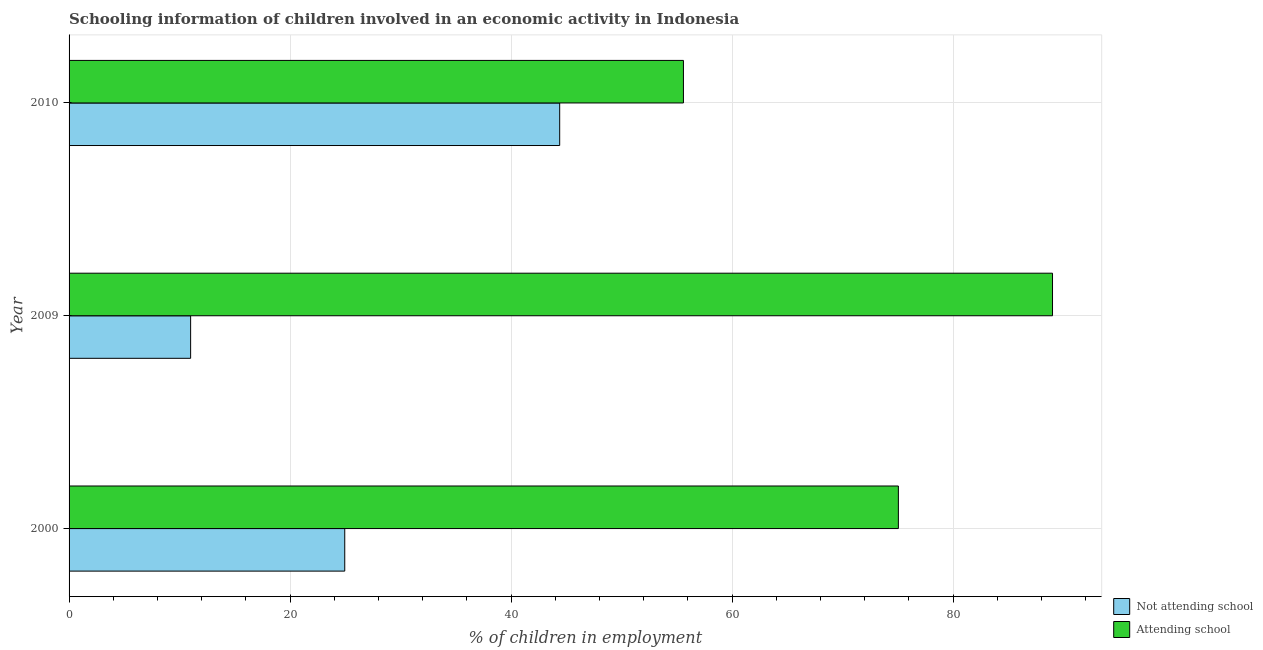Are the number of bars per tick equal to the number of legend labels?
Provide a short and direct response. Yes. Are the number of bars on each tick of the Y-axis equal?
Offer a terse response. Yes. How many bars are there on the 1st tick from the top?
Provide a short and direct response. 2. What is the percentage of employed children who are not attending school in 2000?
Ensure brevity in your answer.  24.95. Across all years, what is the maximum percentage of employed children who are attending school?
Offer a very short reply. 89. Across all years, what is the minimum percentage of employed children who are attending school?
Offer a very short reply. 55.6. What is the total percentage of employed children who are attending school in the graph?
Keep it short and to the point. 219.65. What is the difference between the percentage of employed children who are attending school in 2009 and that in 2010?
Offer a terse response. 33.4. What is the difference between the percentage of employed children who are attending school in 2000 and the percentage of employed children who are not attending school in 2010?
Provide a short and direct response. 30.65. What is the average percentage of employed children who are not attending school per year?
Provide a succinct answer. 26.78. In the year 2000, what is the difference between the percentage of employed children who are attending school and percentage of employed children who are not attending school?
Your answer should be compact. 50.1. In how many years, is the percentage of employed children who are attending school greater than 28 %?
Your answer should be very brief. 3. What is the ratio of the percentage of employed children who are attending school in 2000 to that in 2010?
Give a very brief answer. 1.35. Is the percentage of employed children who are attending school in 2000 less than that in 2010?
Provide a succinct answer. No. What is the difference between the highest and the second highest percentage of employed children who are attending school?
Provide a short and direct response. 13.95. What is the difference between the highest and the lowest percentage of employed children who are attending school?
Your answer should be very brief. 33.4. In how many years, is the percentage of employed children who are not attending school greater than the average percentage of employed children who are not attending school taken over all years?
Your response must be concise. 1. What does the 1st bar from the top in 2009 represents?
Give a very brief answer. Attending school. What does the 1st bar from the bottom in 2000 represents?
Make the answer very short. Not attending school. How many bars are there?
Your answer should be compact. 6. How many years are there in the graph?
Ensure brevity in your answer.  3. What is the difference between two consecutive major ticks on the X-axis?
Offer a very short reply. 20. Does the graph contain grids?
Your answer should be very brief. Yes. How many legend labels are there?
Keep it short and to the point. 2. What is the title of the graph?
Keep it short and to the point. Schooling information of children involved in an economic activity in Indonesia. Does "Fixed telephone" appear as one of the legend labels in the graph?
Offer a terse response. No. What is the label or title of the X-axis?
Give a very brief answer. % of children in employment. What is the % of children in employment of Not attending school in 2000?
Offer a very short reply. 24.95. What is the % of children in employment of Attending school in 2000?
Offer a very short reply. 75.05. What is the % of children in employment of Attending school in 2009?
Make the answer very short. 89. What is the % of children in employment in Not attending school in 2010?
Provide a succinct answer. 44.4. What is the % of children in employment of Attending school in 2010?
Make the answer very short. 55.6. Across all years, what is the maximum % of children in employment of Not attending school?
Give a very brief answer. 44.4. Across all years, what is the maximum % of children in employment in Attending school?
Give a very brief answer. 89. Across all years, what is the minimum % of children in employment of Attending school?
Your answer should be very brief. 55.6. What is the total % of children in employment of Not attending school in the graph?
Offer a very short reply. 80.35. What is the total % of children in employment of Attending school in the graph?
Make the answer very short. 219.65. What is the difference between the % of children in employment of Not attending school in 2000 and that in 2009?
Ensure brevity in your answer.  13.95. What is the difference between the % of children in employment in Attending school in 2000 and that in 2009?
Make the answer very short. -13.95. What is the difference between the % of children in employment of Not attending school in 2000 and that in 2010?
Make the answer very short. -19.45. What is the difference between the % of children in employment of Attending school in 2000 and that in 2010?
Provide a short and direct response. 19.45. What is the difference between the % of children in employment of Not attending school in 2009 and that in 2010?
Provide a short and direct response. -33.4. What is the difference between the % of children in employment in Attending school in 2009 and that in 2010?
Your response must be concise. 33.4. What is the difference between the % of children in employment in Not attending school in 2000 and the % of children in employment in Attending school in 2009?
Make the answer very short. -64.05. What is the difference between the % of children in employment in Not attending school in 2000 and the % of children in employment in Attending school in 2010?
Keep it short and to the point. -30.65. What is the difference between the % of children in employment in Not attending school in 2009 and the % of children in employment in Attending school in 2010?
Your response must be concise. -44.6. What is the average % of children in employment in Not attending school per year?
Ensure brevity in your answer.  26.78. What is the average % of children in employment in Attending school per year?
Your answer should be compact. 73.22. In the year 2000, what is the difference between the % of children in employment of Not attending school and % of children in employment of Attending school?
Make the answer very short. -50.1. In the year 2009, what is the difference between the % of children in employment in Not attending school and % of children in employment in Attending school?
Your answer should be compact. -78. What is the ratio of the % of children in employment of Not attending school in 2000 to that in 2009?
Your answer should be very brief. 2.27. What is the ratio of the % of children in employment of Attending school in 2000 to that in 2009?
Provide a succinct answer. 0.84. What is the ratio of the % of children in employment in Not attending school in 2000 to that in 2010?
Give a very brief answer. 0.56. What is the ratio of the % of children in employment of Attending school in 2000 to that in 2010?
Provide a short and direct response. 1.35. What is the ratio of the % of children in employment of Not attending school in 2009 to that in 2010?
Your answer should be compact. 0.25. What is the ratio of the % of children in employment in Attending school in 2009 to that in 2010?
Your answer should be compact. 1.6. What is the difference between the highest and the second highest % of children in employment of Not attending school?
Offer a terse response. 19.45. What is the difference between the highest and the second highest % of children in employment of Attending school?
Your answer should be very brief. 13.95. What is the difference between the highest and the lowest % of children in employment of Not attending school?
Your answer should be compact. 33.4. What is the difference between the highest and the lowest % of children in employment of Attending school?
Provide a short and direct response. 33.4. 